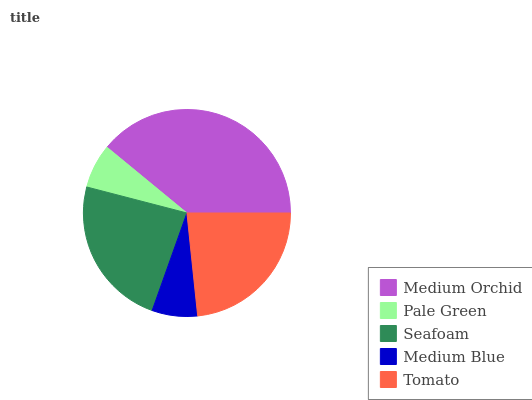Is Pale Green the minimum?
Answer yes or no. Yes. Is Medium Orchid the maximum?
Answer yes or no. Yes. Is Seafoam the minimum?
Answer yes or no. No. Is Seafoam the maximum?
Answer yes or no. No. Is Seafoam greater than Pale Green?
Answer yes or no. Yes. Is Pale Green less than Seafoam?
Answer yes or no. Yes. Is Pale Green greater than Seafoam?
Answer yes or no. No. Is Seafoam less than Pale Green?
Answer yes or no. No. Is Tomato the high median?
Answer yes or no. Yes. Is Tomato the low median?
Answer yes or no. Yes. Is Seafoam the high median?
Answer yes or no. No. Is Pale Green the low median?
Answer yes or no. No. 